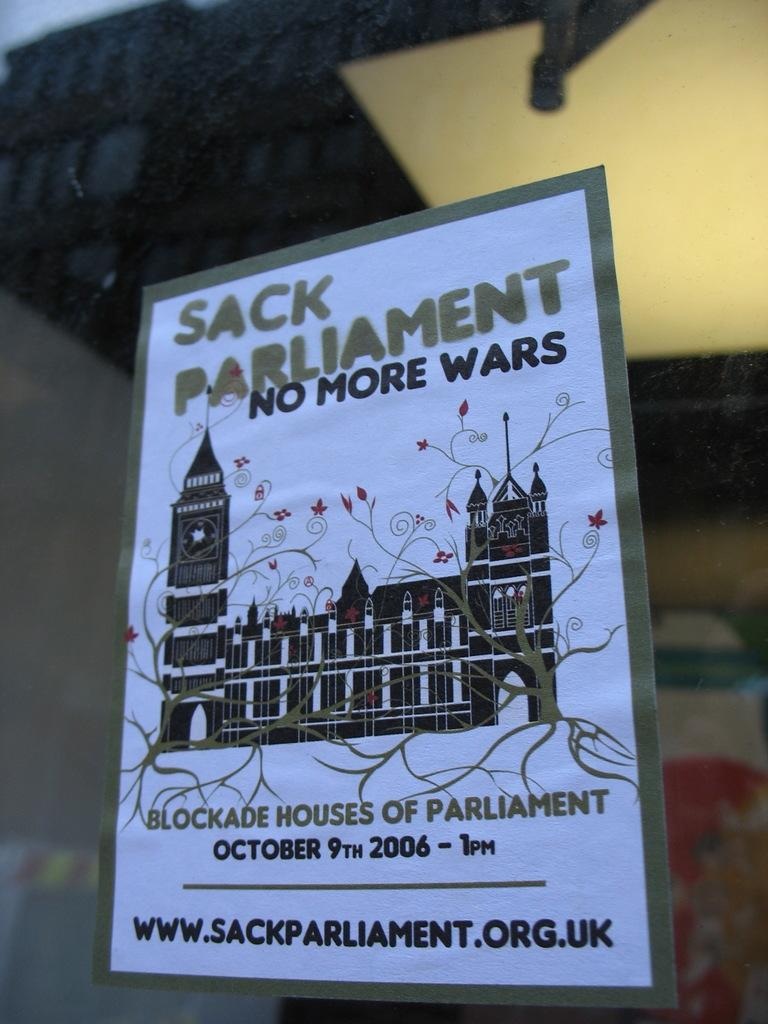<image>
Describe the image concisely. A poster showing a event in which they want to Sack Parliament due to wars 